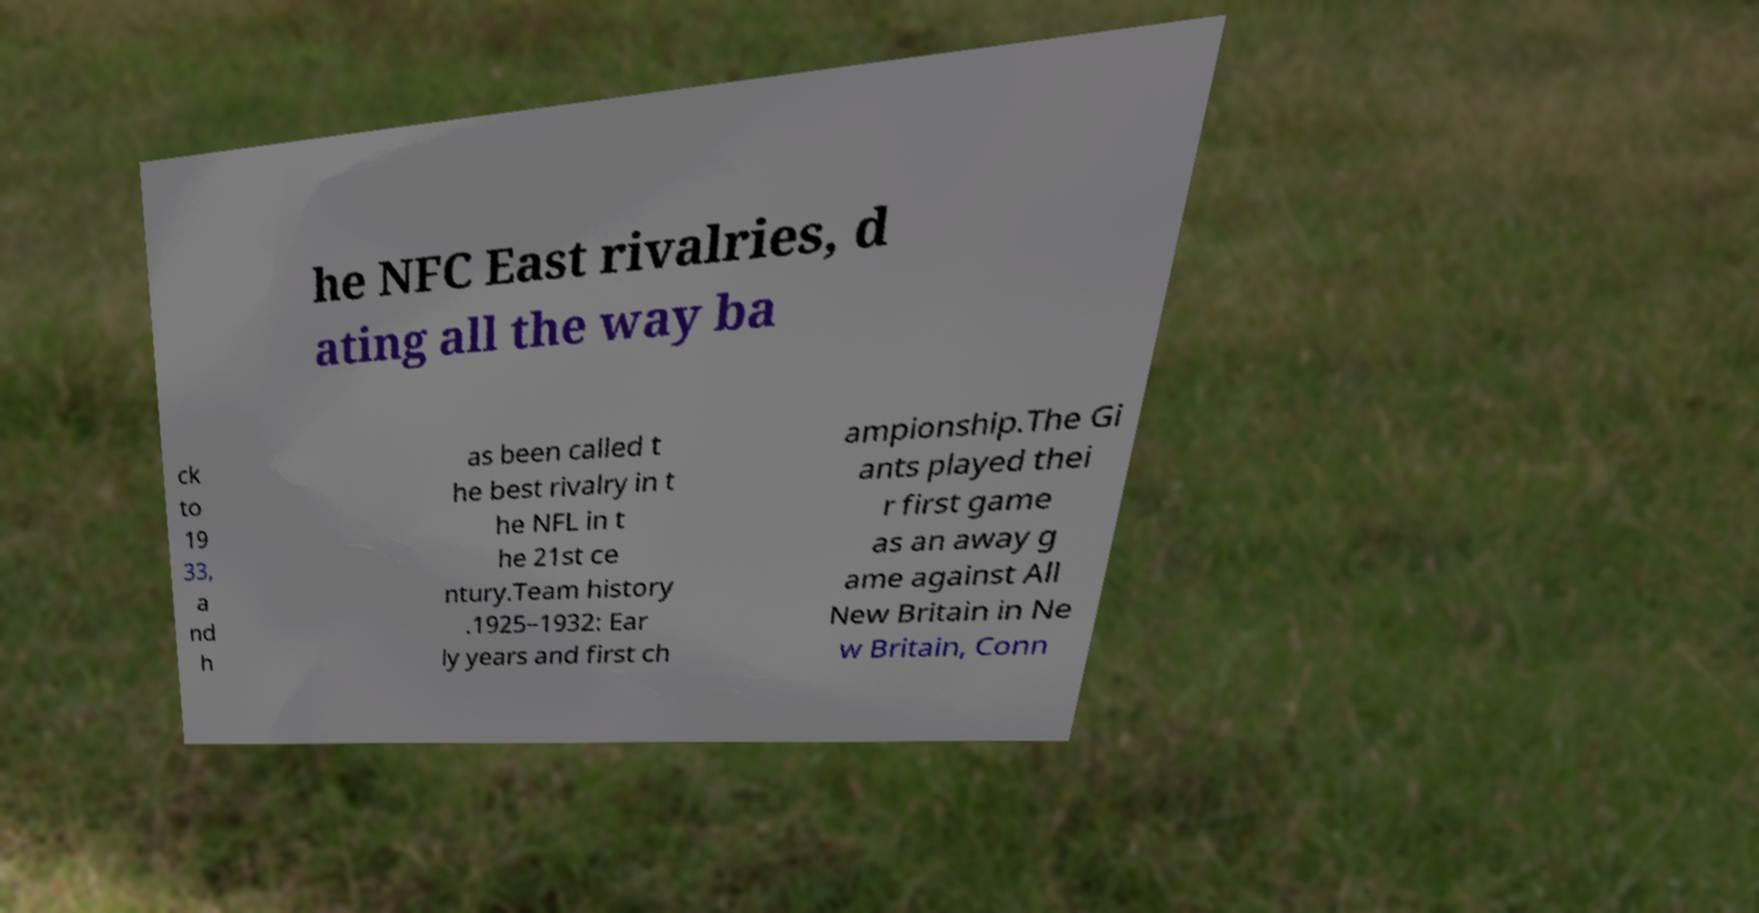Please read and relay the text visible in this image. What does it say? he NFC East rivalries, d ating all the way ba ck to 19 33, a nd h as been called t he best rivalry in t he NFL in t he 21st ce ntury.Team history .1925–1932: Ear ly years and first ch ampionship.The Gi ants played thei r first game as an away g ame against All New Britain in Ne w Britain, Conn 